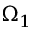<formula> <loc_0><loc_0><loc_500><loc_500>\Omega _ { 1 }</formula> 